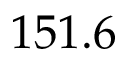<formula> <loc_0><loc_0><loc_500><loc_500>1 5 1 . 6</formula> 